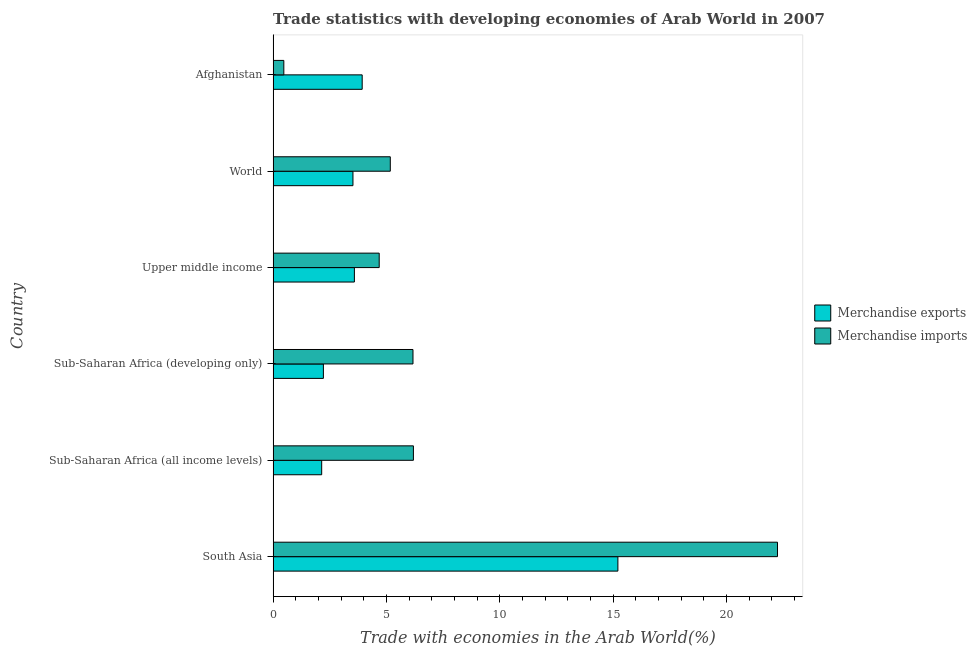Are the number of bars per tick equal to the number of legend labels?
Your answer should be very brief. Yes. Are the number of bars on each tick of the Y-axis equal?
Keep it short and to the point. Yes. How many bars are there on the 1st tick from the bottom?
Your answer should be very brief. 2. What is the label of the 5th group of bars from the top?
Give a very brief answer. Sub-Saharan Africa (all income levels). What is the merchandise imports in World?
Provide a short and direct response. 5.17. Across all countries, what is the maximum merchandise exports?
Offer a terse response. 15.21. Across all countries, what is the minimum merchandise exports?
Give a very brief answer. 2.14. In which country was the merchandise imports maximum?
Make the answer very short. South Asia. In which country was the merchandise imports minimum?
Offer a very short reply. Afghanistan. What is the total merchandise imports in the graph?
Ensure brevity in your answer.  44.94. What is the difference between the merchandise exports in Afghanistan and that in Sub-Saharan Africa (all income levels)?
Provide a short and direct response. 1.79. What is the difference between the merchandise imports in South Asia and the merchandise exports in Afghanistan?
Offer a terse response. 18.33. What is the average merchandise exports per country?
Your answer should be compact. 5.1. What is the difference between the merchandise imports and merchandise exports in South Asia?
Offer a very short reply. 7.04. What is the ratio of the merchandise imports in Sub-Saharan Africa (all income levels) to that in World?
Your answer should be very brief. 1.2. Is the difference between the merchandise exports in Afghanistan and Upper middle income greater than the difference between the merchandise imports in Afghanistan and Upper middle income?
Offer a terse response. Yes. What is the difference between the highest and the second highest merchandise imports?
Provide a succinct answer. 16.07. What is the difference between the highest and the lowest merchandise exports?
Make the answer very short. 13.07. What does the 2nd bar from the bottom in Sub-Saharan Africa (all income levels) represents?
Offer a very short reply. Merchandise imports. How many bars are there?
Offer a terse response. 12. How many countries are there in the graph?
Your answer should be very brief. 6. Are the values on the major ticks of X-axis written in scientific E-notation?
Keep it short and to the point. No. Where does the legend appear in the graph?
Your answer should be compact. Center right. How many legend labels are there?
Provide a succinct answer. 2. How are the legend labels stacked?
Your answer should be compact. Vertical. What is the title of the graph?
Give a very brief answer. Trade statistics with developing economies of Arab World in 2007. What is the label or title of the X-axis?
Offer a very short reply. Trade with economies in the Arab World(%). What is the Trade with economies in the Arab World(%) in Merchandise exports in South Asia?
Keep it short and to the point. 15.21. What is the Trade with economies in the Arab World(%) in Merchandise imports in South Asia?
Provide a succinct answer. 22.26. What is the Trade with economies in the Arab World(%) in Merchandise exports in Sub-Saharan Africa (all income levels)?
Ensure brevity in your answer.  2.14. What is the Trade with economies in the Arab World(%) of Merchandise imports in Sub-Saharan Africa (all income levels)?
Offer a very short reply. 6.19. What is the Trade with economies in the Arab World(%) in Merchandise exports in Sub-Saharan Africa (developing only)?
Your response must be concise. 2.22. What is the Trade with economies in the Arab World(%) in Merchandise imports in Sub-Saharan Africa (developing only)?
Give a very brief answer. 6.17. What is the Trade with economies in the Arab World(%) of Merchandise exports in Upper middle income?
Provide a succinct answer. 3.59. What is the Trade with economies in the Arab World(%) in Merchandise imports in Upper middle income?
Your answer should be very brief. 4.68. What is the Trade with economies in the Arab World(%) in Merchandise exports in World?
Give a very brief answer. 3.52. What is the Trade with economies in the Arab World(%) in Merchandise imports in World?
Your answer should be compact. 5.17. What is the Trade with economies in the Arab World(%) in Merchandise exports in Afghanistan?
Provide a short and direct response. 3.93. What is the Trade with economies in the Arab World(%) of Merchandise imports in Afghanistan?
Your response must be concise. 0.47. Across all countries, what is the maximum Trade with economies in the Arab World(%) in Merchandise exports?
Give a very brief answer. 15.21. Across all countries, what is the maximum Trade with economies in the Arab World(%) in Merchandise imports?
Provide a succinct answer. 22.26. Across all countries, what is the minimum Trade with economies in the Arab World(%) in Merchandise exports?
Offer a very short reply. 2.14. Across all countries, what is the minimum Trade with economies in the Arab World(%) in Merchandise imports?
Give a very brief answer. 0.47. What is the total Trade with economies in the Arab World(%) of Merchandise exports in the graph?
Offer a terse response. 30.61. What is the total Trade with economies in the Arab World(%) in Merchandise imports in the graph?
Provide a short and direct response. 44.94. What is the difference between the Trade with economies in the Arab World(%) in Merchandise exports in South Asia and that in Sub-Saharan Africa (all income levels)?
Give a very brief answer. 13.07. What is the difference between the Trade with economies in the Arab World(%) of Merchandise imports in South Asia and that in Sub-Saharan Africa (all income levels)?
Provide a succinct answer. 16.07. What is the difference between the Trade with economies in the Arab World(%) of Merchandise exports in South Asia and that in Sub-Saharan Africa (developing only)?
Keep it short and to the point. 12.99. What is the difference between the Trade with economies in the Arab World(%) in Merchandise imports in South Asia and that in Sub-Saharan Africa (developing only)?
Provide a succinct answer. 16.08. What is the difference between the Trade with economies in the Arab World(%) of Merchandise exports in South Asia and that in Upper middle income?
Provide a short and direct response. 11.63. What is the difference between the Trade with economies in the Arab World(%) of Merchandise imports in South Asia and that in Upper middle income?
Provide a succinct answer. 17.57. What is the difference between the Trade with economies in the Arab World(%) of Merchandise exports in South Asia and that in World?
Offer a terse response. 11.69. What is the difference between the Trade with economies in the Arab World(%) in Merchandise imports in South Asia and that in World?
Keep it short and to the point. 17.09. What is the difference between the Trade with economies in the Arab World(%) in Merchandise exports in South Asia and that in Afghanistan?
Offer a terse response. 11.28. What is the difference between the Trade with economies in the Arab World(%) of Merchandise imports in South Asia and that in Afghanistan?
Give a very brief answer. 21.78. What is the difference between the Trade with economies in the Arab World(%) in Merchandise exports in Sub-Saharan Africa (all income levels) and that in Sub-Saharan Africa (developing only)?
Keep it short and to the point. -0.08. What is the difference between the Trade with economies in the Arab World(%) in Merchandise imports in Sub-Saharan Africa (all income levels) and that in Sub-Saharan Africa (developing only)?
Make the answer very short. 0.02. What is the difference between the Trade with economies in the Arab World(%) in Merchandise exports in Sub-Saharan Africa (all income levels) and that in Upper middle income?
Make the answer very short. -1.44. What is the difference between the Trade with economies in the Arab World(%) in Merchandise imports in Sub-Saharan Africa (all income levels) and that in Upper middle income?
Provide a succinct answer. 1.51. What is the difference between the Trade with economies in the Arab World(%) in Merchandise exports in Sub-Saharan Africa (all income levels) and that in World?
Offer a very short reply. -1.38. What is the difference between the Trade with economies in the Arab World(%) in Merchandise imports in Sub-Saharan Africa (all income levels) and that in World?
Your answer should be very brief. 1.02. What is the difference between the Trade with economies in the Arab World(%) in Merchandise exports in Sub-Saharan Africa (all income levels) and that in Afghanistan?
Make the answer very short. -1.79. What is the difference between the Trade with economies in the Arab World(%) of Merchandise imports in Sub-Saharan Africa (all income levels) and that in Afghanistan?
Your answer should be compact. 5.72. What is the difference between the Trade with economies in the Arab World(%) in Merchandise exports in Sub-Saharan Africa (developing only) and that in Upper middle income?
Ensure brevity in your answer.  -1.37. What is the difference between the Trade with economies in the Arab World(%) of Merchandise imports in Sub-Saharan Africa (developing only) and that in Upper middle income?
Provide a succinct answer. 1.49. What is the difference between the Trade with economies in the Arab World(%) of Merchandise exports in Sub-Saharan Africa (developing only) and that in World?
Your response must be concise. -1.3. What is the difference between the Trade with economies in the Arab World(%) of Merchandise imports in Sub-Saharan Africa (developing only) and that in World?
Ensure brevity in your answer.  1. What is the difference between the Trade with economies in the Arab World(%) of Merchandise exports in Sub-Saharan Africa (developing only) and that in Afghanistan?
Provide a short and direct response. -1.71. What is the difference between the Trade with economies in the Arab World(%) of Merchandise imports in Sub-Saharan Africa (developing only) and that in Afghanistan?
Give a very brief answer. 5.7. What is the difference between the Trade with economies in the Arab World(%) of Merchandise exports in Upper middle income and that in World?
Offer a very short reply. 0.06. What is the difference between the Trade with economies in the Arab World(%) in Merchandise imports in Upper middle income and that in World?
Give a very brief answer. -0.49. What is the difference between the Trade with economies in the Arab World(%) in Merchandise exports in Upper middle income and that in Afghanistan?
Your answer should be very brief. -0.34. What is the difference between the Trade with economies in the Arab World(%) in Merchandise imports in Upper middle income and that in Afghanistan?
Provide a succinct answer. 4.21. What is the difference between the Trade with economies in the Arab World(%) of Merchandise exports in World and that in Afghanistan?
Your answer should be compact. -0.41. What is the difference between the Trade with economies in the Arab World(%) in Merchandise imports in World and that in Afghanistan?
Give a very brief answer. 4.7. What is the difference between the Trade with economies in the Arab World(%) of Merchandise exports in South Asia and the Trade with economies in the Arab World(%) of Merchandise imports in Sub-Saharan Africa (all income levels)?
Offer a terse response. 9.02. What is the difference between the Trade with economies in the Arab World(%) in Merchandise exports in South Asia and the Trade with economies in the Arab World(%) in Merchandise imports in Sub-Saharan Africa (developing only)?
Make the answer very short. 9.04. What is the difference between the Trade with economies in the Arab World(%) in Merchandise exports in South Asia and the Trade with economies in the Arab World(%) in Merchandise imports in Upper middle income?
Provide a succinct answer. 10.53. What is the difference between the Trade with economies in the Arab World(%) in Merchandise exports in South Asia and the Trade with economies in the Arab World(%) in Merchandise imports in World?
Your response must be concise. 10.04. What is the difference between the Trade with economies in the Arab World(%) in Merchandise exports in South Asia and the Trade with economies in the Arab World(%) in Merchandise imports in Afghanistan?
Make the answer very short. 14.74. What is the difference between the Trade with economies in the Arab World(%) of Merchandise exports in Sub-Saharan Africa (all income levels) and the Trade with economies in the Arab World(%) of Merchandise imports in Sub-Saharan Africa (developing only)?
Your answer should be very brief. -4.03. What is the difference between the Trade with economies in the Arab World(%) in Merchandise exports in Sub-Saharan Africa (all income levels) and the Trade with economies in the Arab World(%) in Merchandise imports in Upper middle income?
Your response must be concise. -2.54. What is the difference between the Trade with economies in the Arab World(%) in Merchandise exports in Sub-Saharan Africa (all income levels) and the Trade with economies in the Arab World(%) in Merchandise imports in World?
Keep it short and to the point. -3.03. What is the difference between the Trade with economies in the Arab World(%) of Merchandise exports in Sub-Saharan Africa (all income levels) and the Trade with economies in the Arab World(%) of Merchandise imports in Afghanistan?
Provide a short and direct response. 1.67. What is the difference between the Trade with economies in the Arab World(%) of Merchandise exports in Sub-Saharan Africa (developing only) and the Trade with economies in the Arab World(%) of Merchandise imports in Upper middle income?
Make the answer very short. -2.46. What is the difference between the Trade with economies in the Arab World(%) of Merchandise exports in Sub-Saharan Africa (developing only) and the Trade with economies in the Arab World(%) of Merchandise imports in World?
Give a very brief answer. -2.95. What is the difference between the Trade with economies in the Arab World(%) of Merchandise exports in Sub-Saharan Africa (developing only) and the Trade with economies in the Arab World(%) of Merchandise imports in Afghanistan?
Make the answer very short. 1.75. What is the difference between the Trade with economies in the Arab World(%) in Merchandise exports in Upper middle income and the Trade with economies in the Arab World(%) in Merchandise imports in World?
Your answer should be compact. -1.58. What is the difference between the Trade with economies in the Arab World(%) of Merchandise exports in Upper middle income and the Trade with economies in the Arab World(%) of Merchandise imports in Afghanistan?
Provide a short and direct response. 3.11. What is the difference between the Trade with economies in the Arab World(%) in Merchandise exports in World and the Trade with economies in the Arab World(%) in Merchandise imports in Afghanistan?
Your response must be concise. 3.05. What is the average Trade with economies in the Arab World(%) in Merchandise exports per country?
Offer a terse response. 5.1. What is the average Trade with economies in the Arab World(%) in Merchandise imports per country?
Give a very brief answer. 7.49. What is the difference between the Trade with economies in the Arab World(%) in Merchandise exports and Trade with economies in the Arab World(%) in Merchandise imports in South Asia?
Your answer should be very brief. -7.04. What is the difference between the Trade with economies in the Arab World(%) in Merchandise exports and Trade with economies in the Arab World(%) in Merchandise imports in Sub-Saharan Africa (all income levels)?
Provide a succinct answer. -4.05. What is the difference between the Trade with economies in the Arab World(%) in Merchandise exports and Trade with economies in the Arab World(%) in Merchandise imports in Sub-Saharan Africa (developing only)?
Provide a succinct answer. -3.95. What is the difference between the Trade with economies in the Arab World(%) of Merchandise exports and Trade with economies in the Arab World(%) of Merchandise imports in Upper middle income?
Ensure brevity in your answer.  -1.09. What is the difference between the Trade with economies in the Arab World(%) of Merchandise exports and Trade with economies in the Arab World(%) of Merchandise imports in World?
Ensure brevity in your answer.  -1.65. What is the difference between the Trade with economies in the Arab World(%) in Merchandise exports and Trade with economies in the Arab World(%) in Merchandise imports in Afghanistan?
Offer a terse response. 3.46. What is the ratio of the Trade with economies in the Arab World(%) of Merchandise exports in South Asia to that in Sub-Saharan Africa (all income levels)?
Your response must be concise. 7.1. What is the ratio of the Trade with economies in the Arab World(%) in Merchandise imports in South Asia to that in Sub-Saharan Africa (all income levels)?
Offer a very short reply. 3.6. What is the ratio of the Trade with economies in the Arab World(%) in Merchandise exports in South Asia to that in Sub-Saharan Africa (developing only)?
Your answer should be very brief. 6.86. What is the ratio of the Trade with economies in the Arab World(%) in Merchandise imports in South Asia to that in Sub-Saharan Africa (developing only)?
Your response must be concise. 3.61. What is the ratio of the Trade with economies in the Arab World(%) in Merchandise exports in South Asia to that in Upper middle income?
Offer a very short reply. 4.24. What is the ratio of the Trade with economies in the Arab World(%) of Merchandise imports in South Asia to that in Upper middle income?
Offer a terse response. 4.75. What is the ratio of the Trade with economies in the Arab World(%) in Merchandise exports in South Asia to that in World?
Offer a very short reply. 4.32. What is the ratio of the Trade with economies in the Arab World(%) of Merchandise imports in South Asia to that in World?
Offer a very short reply. 4.3. What is the ratio of the Trade with economies in the Arab World(%) of Merchandise exports in South Asia to that in Afghanistan?
Ensure brevity in your answer.  3.87. What is the ratio of the Trade with economies in the Arab World(%) in Merchandise imports in South Asia to that in Afghanistan?
Make the answer very short. 47.11. What is the ratio of the Trade with economies in the Arab World(%) in Merchandise exports in Sub-Saharan Africa (all income levels) to that in Sub-Saharan Africa (developing only)?
Offer a very short reply. 0.97. What is the ratio of the Trade with economies in the Arab World(%) of Merchandise imports in Sub-Saharan Africa (all income levels) to that in Sub-Saharan Africa (developing only)?
Your answer should be compact. 1. What is the ratio of the Trade with economies in the Arab World(%) in Merchandise exports in Sub-Saharan Africa (all income levels) to that in Upper middle income?
Your response must be concise. 0.6. What is the ratio of the Trade with economies in the Arab World(%) in Merchandise imports in Sub-Saharan Africa (all income levels) to that in Upper middle income?
Offer a very short reply. 1.32. What is the ratio of the Trade with economies in the Arab World(%) of Merchandise exports in Sub-Saharan Africa (all income levels) to that in World?
Keep it short and to the point. 0.61. What is the ratio of the Trade with economies in the Arab World(%) of Merchandise imports in Sub-Saharan Africa (all income levels) to that in World?
Your answer should be compact. 1.2. What is the ratio of the Trade with economies in the Arab World(%) of Merchandise exports in Sub-Saharan Africa (all income levels) to that in Afghanistan?
Your answer should be compact. 0.55. What is the ratio of the Trade with economies in the Arab World(%) in Merchandise imports in Sub-Saharan Africa (all income levels) to that in Afghanistan?
Your response must be concise. 13.1. What is the ratio of the Trade with economies in the Arab World(%) in Merchandise exports in Sub-Saharan Africa (developing only) to that in Upper middle income?
Offer a terse response. 0.62. What is the ratio of the Trade with economies in the Arab World(%) in Merchandise imports in Sub-Saharan Africa (developing only) to that in Upper middle income?
Offer a very short reply. 1.32. What is the ratio of the Trade with economies in the Arab World(%) in Merchandise exports in Sub-Saharan Africa (developing only) to that in World?
Offer a very short reply. 0.63. What is the ratio of the Trade with economies in the Arab World(%) in Merchandise imports in Sub-Saharan Africa (developing only) to that in World?
Offer a very short reply. 1.19. What is the ratio of the Trade with economies in the Arab World(%) in Merchandise exports in Sub-Saharan Africa (developing only) to that in Afghanistan?
Your response must be concise. 0.56. What is the ratio of the Trade with economies in the Arab World(%) in Merchandise imports in Sub-Saharan Africa (developing only) to that in Afghanistan?
Ensure brevity in your answer.  13.07. What is the ratio of the Trade with economies in the Arab World(%) in Merchandise exports in Upper middle income to that in World?
Offer a very short reply. 1.02. What is the ratio of the Trade with economies in the Arab World(%) in Merchandise imports in Upper middle income to that in World?
Provide a short and direct response. 0.91. What is the ratio of the Trade with economies in the Arab World(%) of Merchandise exports in Upper middle income to that in Afghanistan?
Offer a very short reply. 0.91. What is the ratio of the Trade with economies in the Arab World(%) of Merchandise imports in Upper middle income to that in Afghanistan?
Keep it short and to the point. 9.91. What is the ratio of the Trade with economies in the Arab World(%) in Merchandise exports in World to that in Afghanistan?
Provide a succinct answer. 0.9. What is the ratio of the Trade with economies in the Arab World(%) in Merchandise imports in World to that in Afghanistan?
Give a very brief answer. 10.95. What is the difference between the highest and the second highest Trade with economies in the Arab World(%) of Merchandise exports?
Offer a very short reply. 11.28. What is the difference between the highest and the second highest Trade with economies in the Arab World(%) in Merchandise imports?
Your answer should be compact. 16.07. What is the difference between the highest and the lowest Trade with economies in the Arab World(%) of Merchandise exports?
Ensure brevity in your answer.  13.07. What is the difference between the highest and the lowest Trade with economies in the Arab World(%) of Merchandise imports?
Make the answer very short. 21.78. 